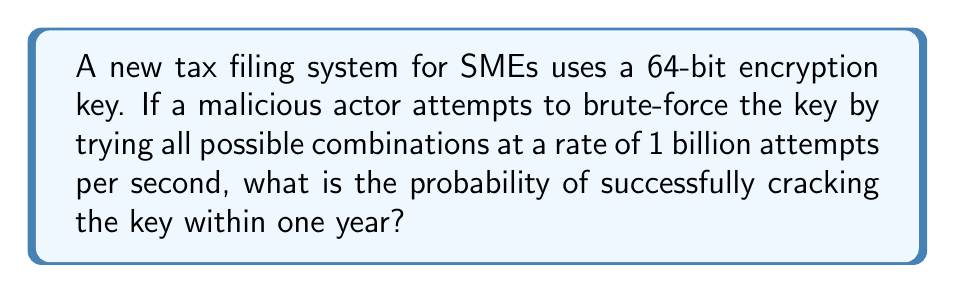Help me with this question. Let's approach this step-by-step:

1) First, calculate the total number of possible keys:
   For a 64-bit key, there are $2^{64}$ possible combinations.

2) Calculate how many attempts can be made in one year:
   1 billion attempts per second = $10^9$ attempts/second
   Seconds in a year = 365 * 24 * 60 * 60 = 31,536,000
   Attempts in a year = $10^9 * 31,536,000 = 3.1536 * 10^{16}$

3) The probability of success is the number of attempts divided by the total number of possible keys:

   $$P(\text{success}) = \frac{\text{Number of attempts}}{\text{Total possible keys}}$$

   $$P(\text{success}) = \frac{3.1536 * 10^{16}}{2^{64}}$$

4) Simplify:
   $2^{64} = 1.8447 * 10^{19}$

   $$P(\text{success}) = \frac{3.1536 * 10^{16}}{1.8447 * 10^{19}} = 0.00171 = 0.171\%$$
Answer: $0.171\%$ 